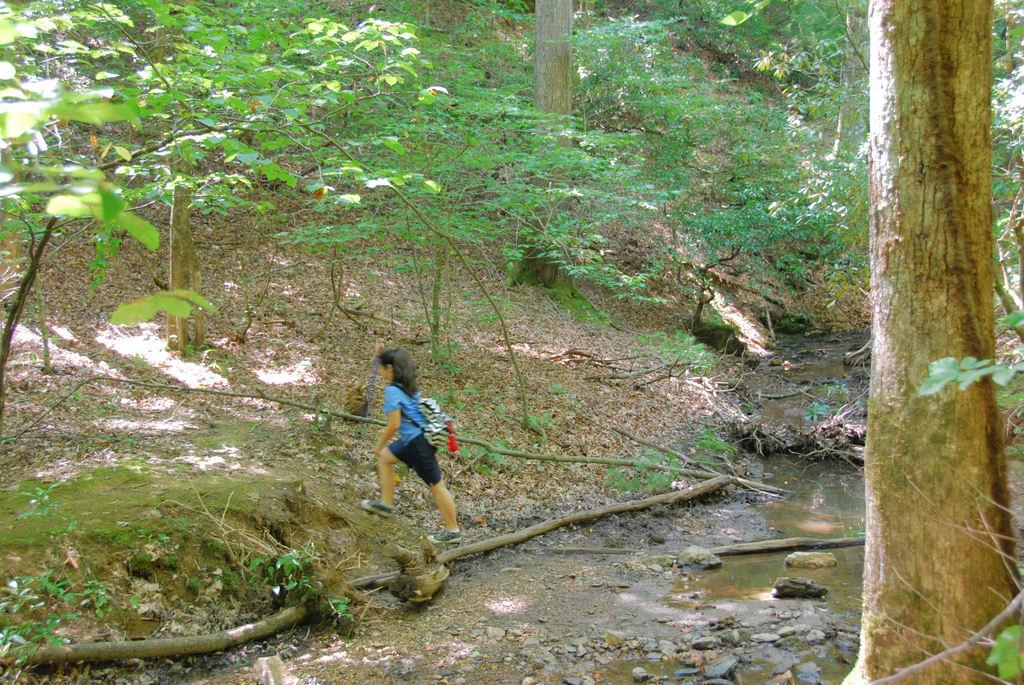Who is the main subject in the picture? There is a girl in the picture. What is the girl wearing? The girl is wearing a bag. What is the girl doing in the image? The girl is walking on the land. What can be seen in the background of the image? There is water and trees visible in the image. What type of bread is the farmer holding in the image? There is no farmer or bread present in the image; it features a girl walking on the land with water and trees in the background. 